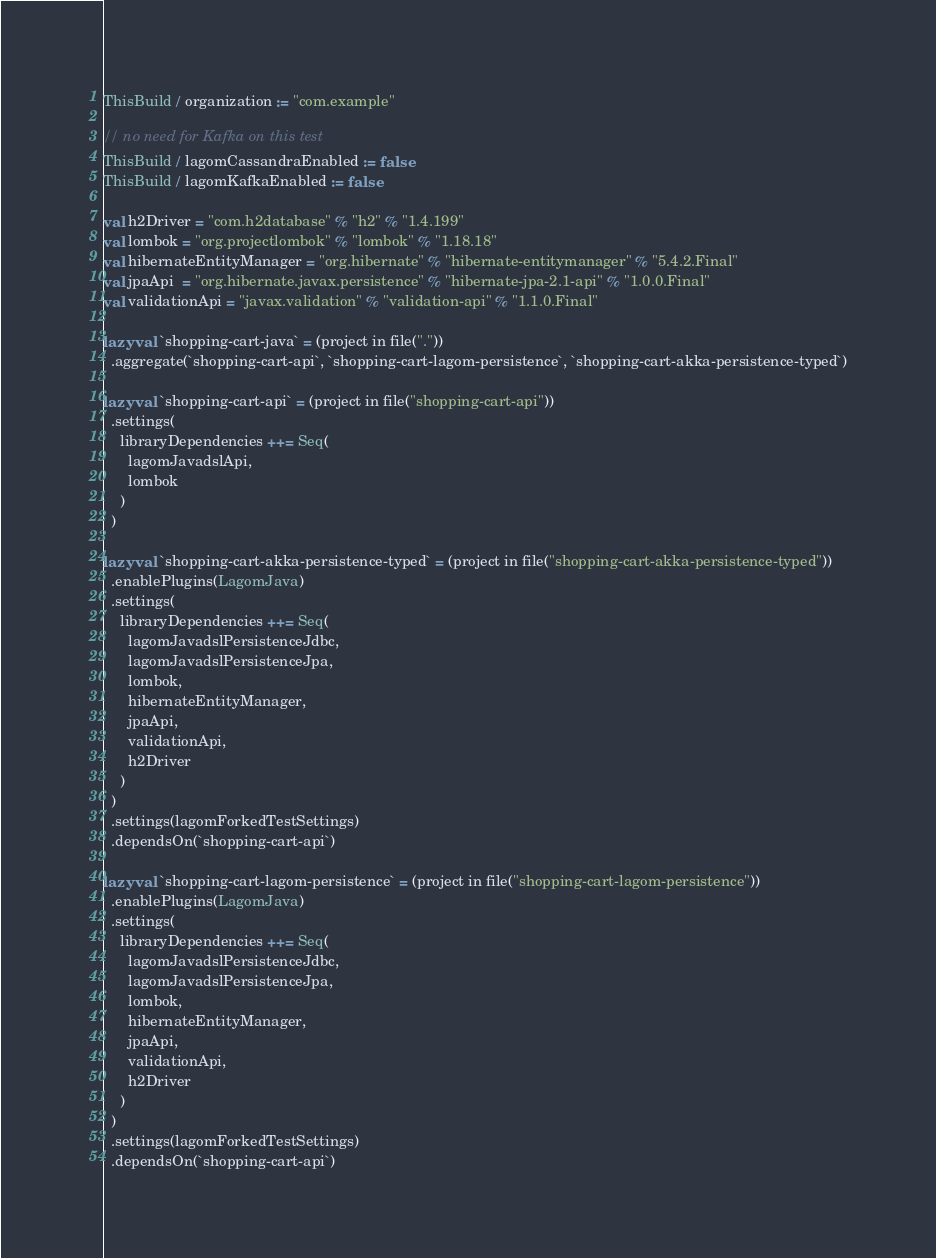Convert code to text. <code><loc_0><loc_0><loc_500><loc_500><_Scala_>ThisBuild / organization := "com.example"

// no need for Kafka on this test
ThisBuild / lagomCassandraEnabled := false
ThisBuild / lagomKafkaEnabled := false

val h2Driver = "com.h2database" % "h2" % "1.4.199"
val lombok = "org.projectlombok" % "lombok" % "1.18.18"
val hibernateEntityManager = "org.hibernate" % "hibernate-entitymanager" % "5.4.2.Final"
val jpaApi  = "org.hibernate.javax.persistence" % "hibernate-jpa-2.1-api" % "1.0.0.Final"
val validationApi = "javax.validation" % "validation-api" % "1.1.0.Final"

lazy val `shopping-cart-java` = (project in file("."))
  .aggregate(`shopping-cart-api`, `shopping-cart-lagom-persistence`, `shopping-cart-akka-persistence-typed`)

lazy val `shopping-cart-api` = (project in file("shopping-cart-api"))
  .settings(
    libraryDependencies ++= Seq(
      lagomJavadslApi,
      lombok
    )
  )

lazy val `shopping-cart-akka-persistence-typed` = (project in file("shopping-cart-akka-persistence-typed"))
  .enablePlugins(LagomJava)
  .settings(
    libraryDependencies ++= Seq(
      lagomJavadslPersistenceJdbc,
      lagomJavadslPersistenceJpa,
      lombok,
      hibernateEntityManager,
      jpaApi,
      validationApi,
      h2Driver
    )
  )
  .settings(lagomForkedTestSettings)
  .dependsOn(`shopping-cart-api`)

lazy val `shopping-cart-lagom-persistence` = (project in file("shopping-cart-lagom-persistence"))
  .enablePlugins(LagomJava)
  .settings(
    libraryDependencies ++= Seq(
      lagomJavadslPersistenceJdbc,
      lagomJavadslPersistenceJpa,
      lombok,
      hibernateEntityManager,
      jpaApi,
      validationApi,
      h2Driver
    )
  )
  .settings(lagomForkedTestSettings)
  .dependsOn(`shopping-cart-api`)
</code> 